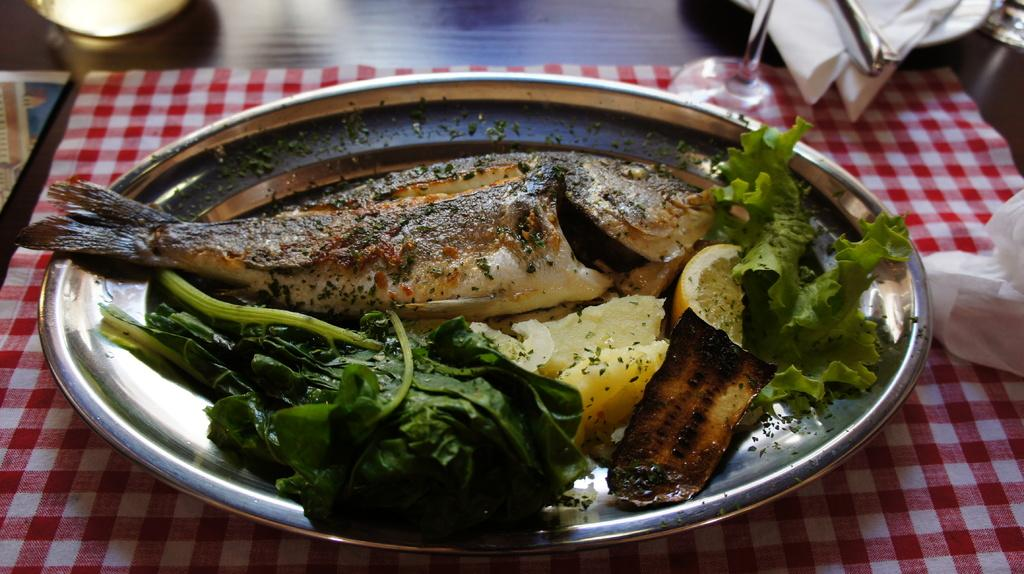What type of furniture is present in the image? There is a table in the image. What is covering the table? There is a red cloth on the table. What is placed on top of the red cloth? There is a steel plate on the table. What food items are on the plate? There is a fish and green vegetables on the plate. What historical discovery was made by the fish on the plate? The image does not depict any historical discovery made by the fish on the plate. The fish is simply a food item on the plate. 